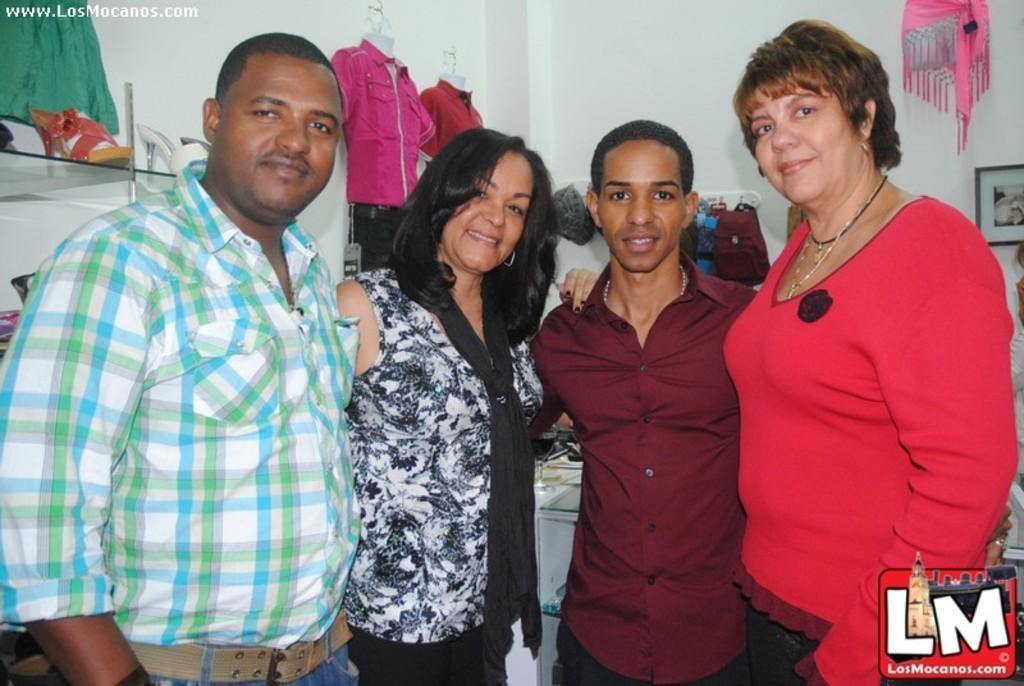Could you give a brief overview of what you see in this image? In this image four people were standing and posing for the picture. At the back side there are bags, dresses hanged on the wall. At the left side of the image there are candles placed on the glass table. 